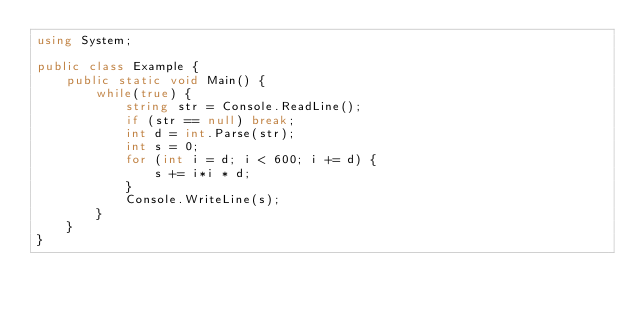Convert code to text. <code><loc_0><loc_0><loc_500><loc_500><_C#_>using System;

public class Example {
    public static void Main() {
        while(true) {
            string str = Console.ReadLine();
            if (str == null) break;
            int d = int.Parse(str);
            int s = 0;
            for (int i = d; i < 600; i += d) {
                s += i*i * d;
            }
            Console.WriteLine(s);
        }
    }
}</code> 